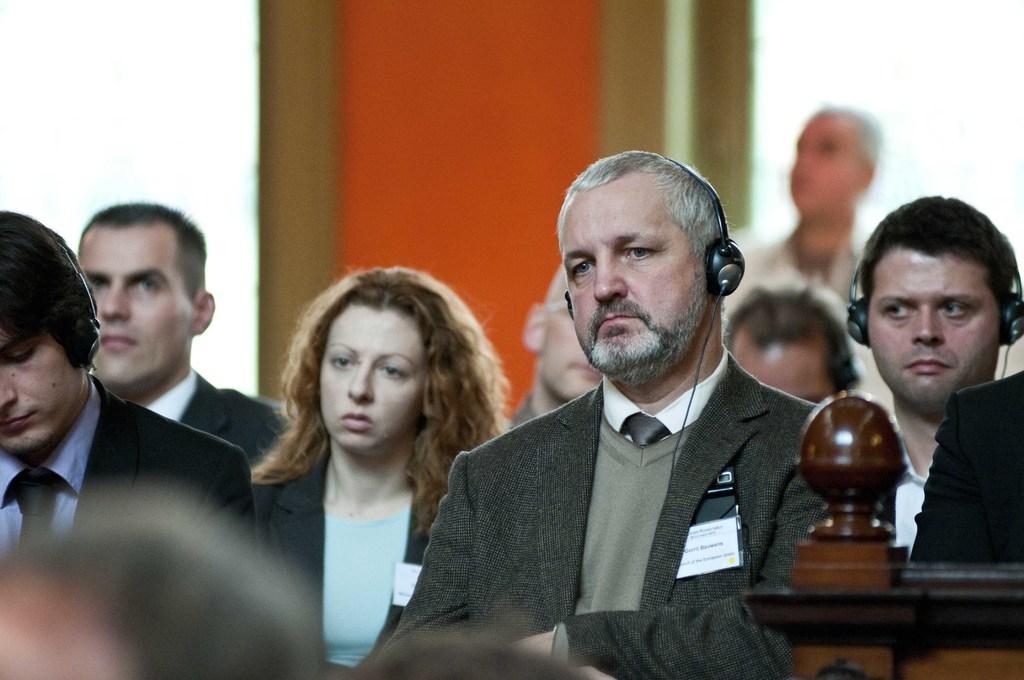Please provide a concise description of this image. In this image we can see people sitting. In the background there is a wall and we can see a man standing. 